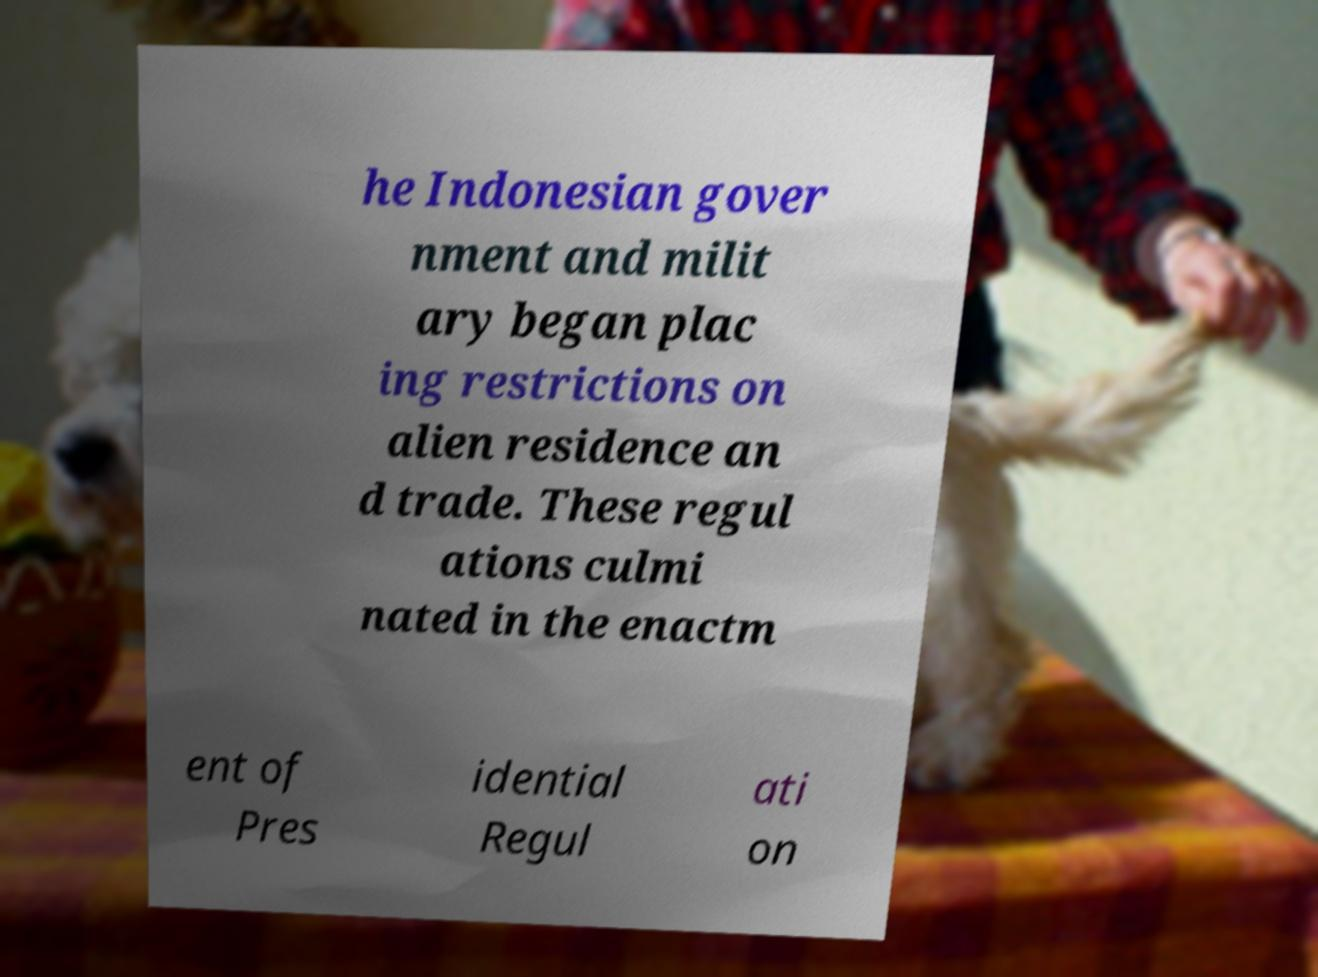Can you read and provide the text displayed in the image?This photo seems to have some interesting text. Can you extract and type it out for me? he Indonesian gover nment and milit ary began plac ing restrictions on alien residence an d trade. These regul ations culmi nated in the enactm ent of Pres idential Regul ati on 